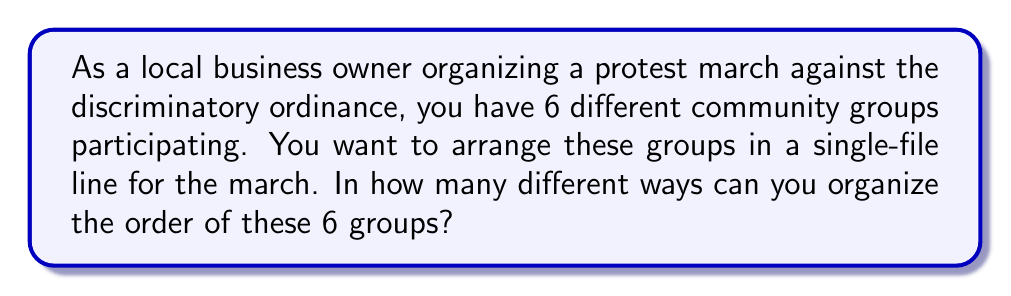What is the answer to this math problem? Let's approach this step-by-step:

1) This problem is a straightforward application of permutations. We are arranging 6 distinct groups in a line, where the order matters.

2) In permutation problems, when we need to arrange all n distinct objects, the number of ways to do so is given by n!

3) In this case, n = 6 (the number of community groups)

4) Therefore, the number of ways to arrange 6 groups is:

   $$6! = 6 \times 5 \times 4 \times 3 \times 2 \times 1 = 720$$

5) We can break this down further:
   - The first group can be chosen in 6 ways
   - For each of these, the second group can be chosen in 5 ways
   - For each of these, the third group can be chosen in 4 ways
   - And so on...

6) This multiplication principle leads us to the same result:

   $$6 \times 5 \times 4 \times 3 \times 2 \times 1 = 720$$

Thus, there are 720 different ways to organize the 6 groups in the protest march.
Answer: 720 ways 